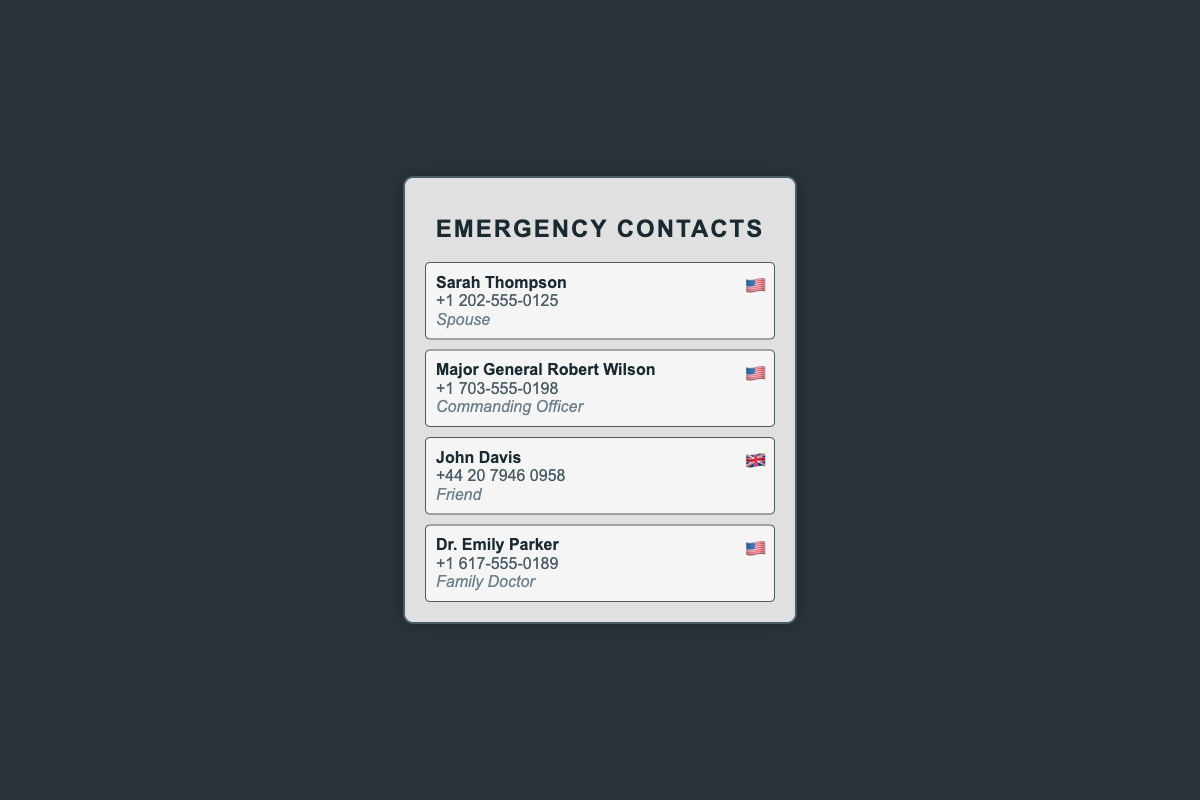What is the name of the spouse? The spouse's name is listed in the document under emergency contacts as Sarah Thompson.
Answer: Sarah Thompson What is the phone number of Major General Robert Wilson? The document provides Major General Robert Wilson's contact number as +1 703-555-0198.
Answer: +1 703-555-0198 Who is listed as the family doctor? The document includes Dr. Emily Parker as the family doctor among the emergency contacts.
Answer: Dr. Emily Parker How many contacts have a American flag icon? By checking the flag icons next to each contact, three are identified with an American flag.
Answer: 3 Which contact has a British flag icon? According to the document, John Davis has a British flag icon next to his name.
Answer: John Davis What is the relationship of Sarah Thompson to the military officer? The document indicates that Sarah Thompson is the spouse of the officer.
Answer: Spouse What type of document is this? This document is specifically designed as a business card focused on emergency contacts.
Answer: Business card What city does John Davis's contact number represent? The area code in John Davis's contact number +44 20 suggests it is in London, UK.
Answer: London, UK 